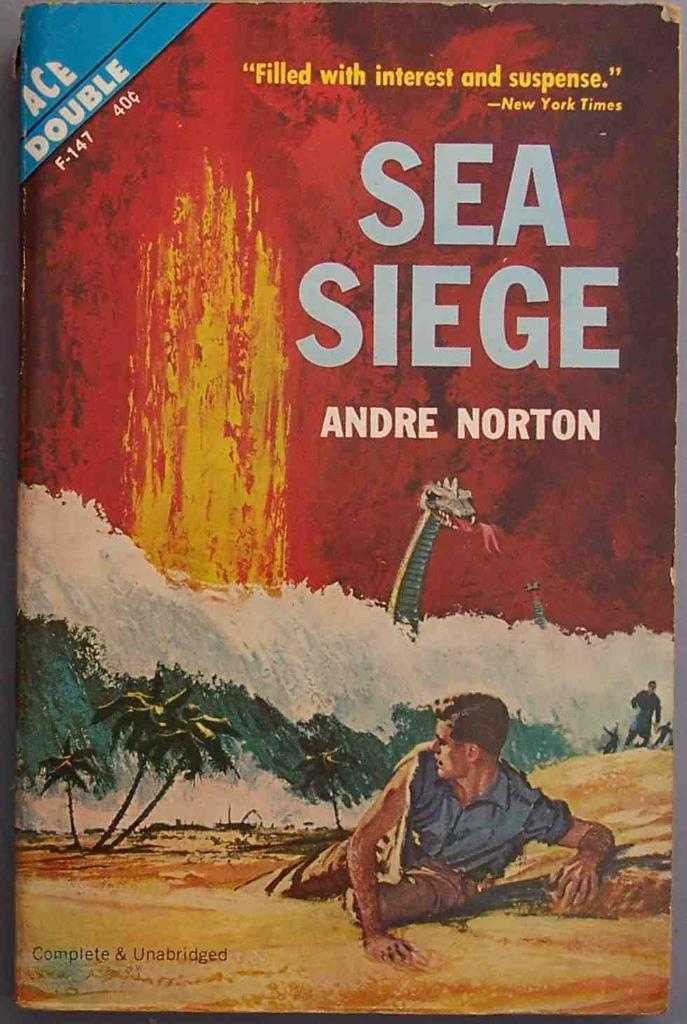Provide a one-sentence caption for the provided image. the cover of SEA SIEGE book by Andre Norton. 